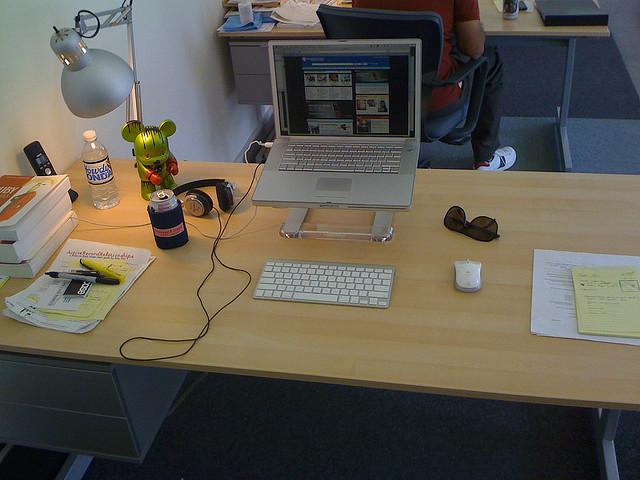Is the desk clean?
Concise answer only. Yes. How many items are on the desk?
Short answer required. 12. What is the figurine animal?
Short answer required. Mouse. What color is the lid of the water bottle?
Keep it brief. White. Is the computer turned on?
Quick response, please. Yes. Is this desk messy?
Short answer required. No. What is on the desk?
Concise answer only. Computer. What brand is the keyboard?
Concise answer only. Apple. What color is the computer mouse on the table?
Quick response, please. White. What do the keyboard, mouse and laptop all have in common?
Give a very brief answer. Apple. What does the paper on the left side say at top?
Short answer required. Unknown. What color is the floor?
Answer briefly. Blue. What is the objects on the desk?
Be succinct. Computer. What color is the smiling object?
Answer briefly. Green. Is the table organized?
Concise answer only. Yes. What kind of beverage does the user seem to enjoy?
Short answer required. Beer. Is that a comic book on the left side?
Be succinct. No. What color is the doll's eye's?
Short answer required. Black. Is this a home office?
Give a very brief answer. No. Is the light pointed toward the camera?
Concise answer only. No. What color glasses are on the desk?
Keep it brief. Black. Is there more than 20 icons on the desktop?
Write a very short answer. No. Is there a trash can in the room?
Short answer required. No. Is there a headset?
Give a very brief answer. Yes. Are there scissors on the desk?
Give a very brief answer. No. Is this cluttered?
Give a very brief answer. No. What color is the laptop?
Write a very short answer. Gray. Is there a cell phone in the photo?
Give a very brief answer. No. 